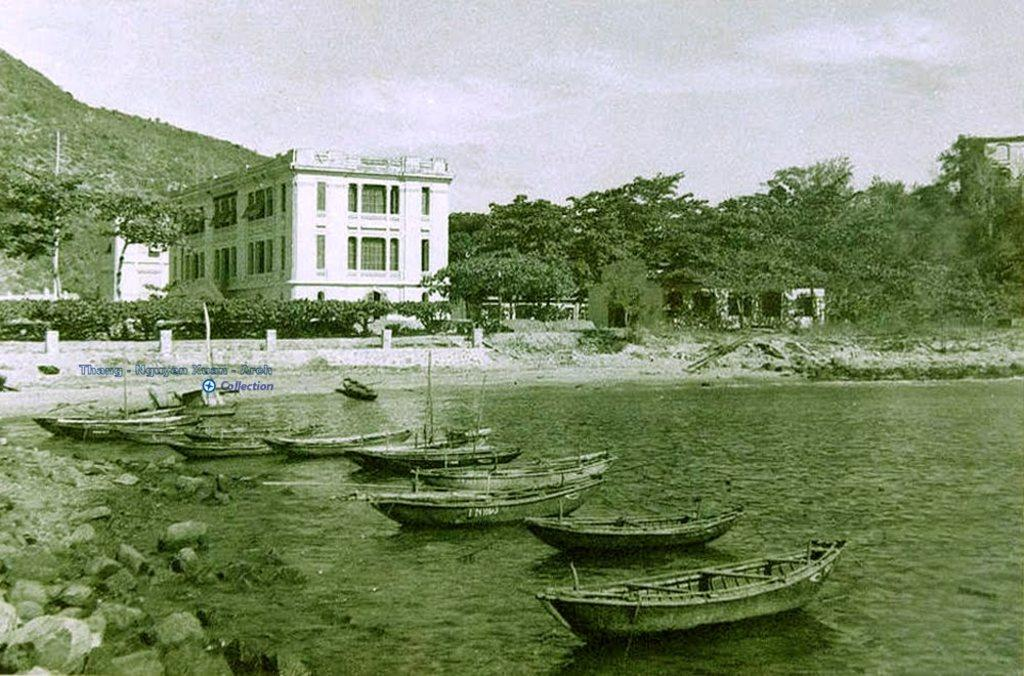What type of natural elements can be seen in the image? There are rocks, water, trees, and a hill visible in the image. What man-made structures are present in the image? There are buildings and boats visible in the image. What is the condition of the sky in the image? The sky is visible in the image. Can you describe the unspecified objects in the image? Unfortunately, the facts do not provide any details about the unspecified objects. How many elements can be seen in the image? There are at least nine elements visible in the image: rocks, water, boats, buildings, trees, a hill, the sky, unspecified objects, and a watermark. What type of rod can be seen in the image? There is no rod present in the image. Is there any motion or movement happening in the image? The image is a still photograph, so there is no motion or movement visible. What type of pollution can be seen in the image? There is no mention of pollution in the image, and it is not visible in the provided facts. 